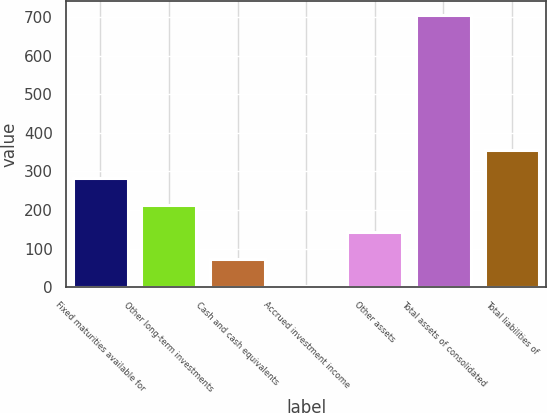Convert chart. <chart><loc_0><loc_0><loc_500><loc_500><bar_chart><fcel>Fixed maturities available for<fcel>Other long-term investments<fcel>Cash and cash equivalents<fcel>Accrued investment income<fcel>Other assets<fcel>Total assets of consolidated<fcel>Total liabilities of<nl><fcel>284.2<fcel>213.9<fcel>73.3<fcel>3<fcel>143.6<fcel>706<fcel>354.5<nl></chart> 